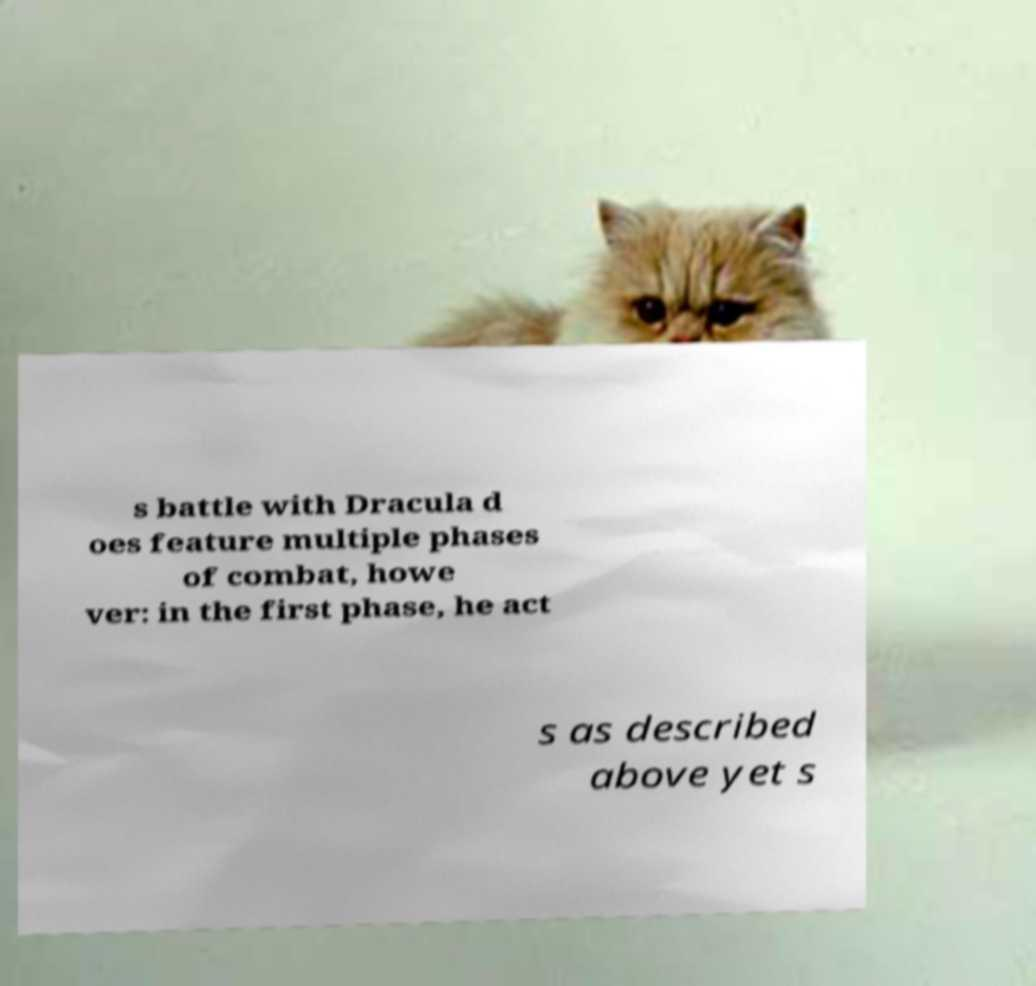Can you read and provide the text displayed in the image?This photo seems to have some interesting text. Can you extract and type it out for me? s battle with Dracula d oes feature multiple phases of combat, howe ver: in the first phase, he act s as described above yet s 